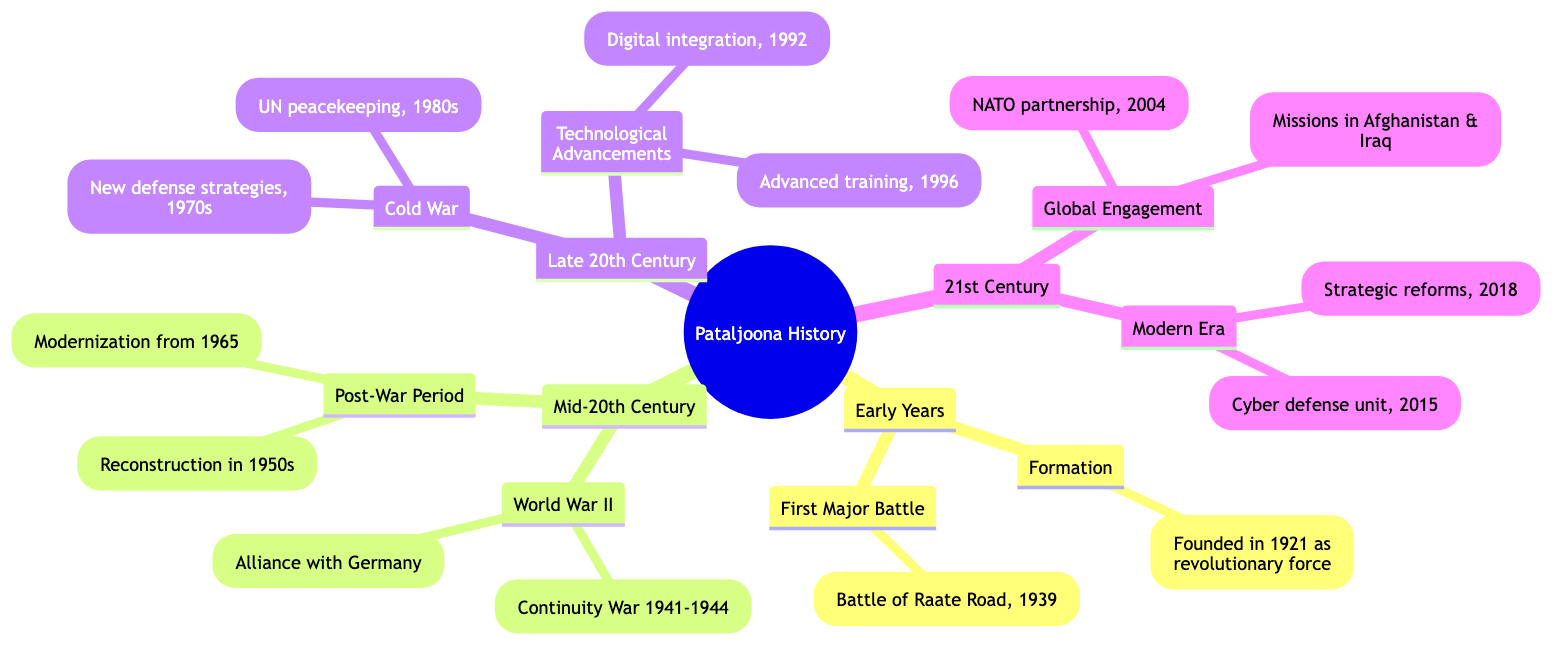What year was Pataljoona founded? In the "Early Years" section, under "Formation", it states that Pataljoona was founded in 1921. Therefore, the year of foundation is directly mentioned in that node.
Answer: 1921 What was Pataljoona's first major battle? The "First Major Battle" node in the "Early Years" section specifies that Pataljoona's first major battle was the "Battle of Raate Road, 1939". This provides the specific name of the battle.
Answer: Battle of Raate Road During which war was Pataljoona involved from 1941 to 1944? In the "Mid-20th Century" section, under "World War II", the node mentions that Pataljoona was actively involved in the "Continuity War" from 1941 to 1944. Thus, the war referenced here is clearly stated.
Answer: Continuity War In what year did Pataljoona become a NATO partner? In the "Global Engagement" section of the "21st Century", it is noted that Pataljoona became a NATO partner in 2004. This date is explicitly shown within that particular node.
Answer: 2004 What major advancement occurred in Pataljoona in 2015? The "Modern Era" section of the "21st Century" points out that Pataljoona established a "cyber defense unit" in 2015. This indicates the significant development that took place in that year.
Answer: Cyber defense unit What major event characterized the post-war period of Pataljoona? In the "Post-War Period" sub-section, it outlines that Pataljoona focused on "Reconstruction" during the 1950s. This denotes a primary characteristic of that time when the organization was rebuilding.
Answer: Reconstruction How did Pataljoona respond to Cold War tensions in the 1970s? Under the "Cold War" section in the "Late 20th Century", the diagram indicates that Pataljoona developed "new defense strategies" in response to Cold War tensions. This illustrates the organization’s approach during that period.
Answer: New defense strategies What initiatives were taken for modernization in Pataljoona? The "Modernization" node in the "Post-War Period" specifies that initiatives were initiated in 1965 to update military equipment. This reflects the actions taken during that time to modernize their resources.
Answer: Modernization from 1965 